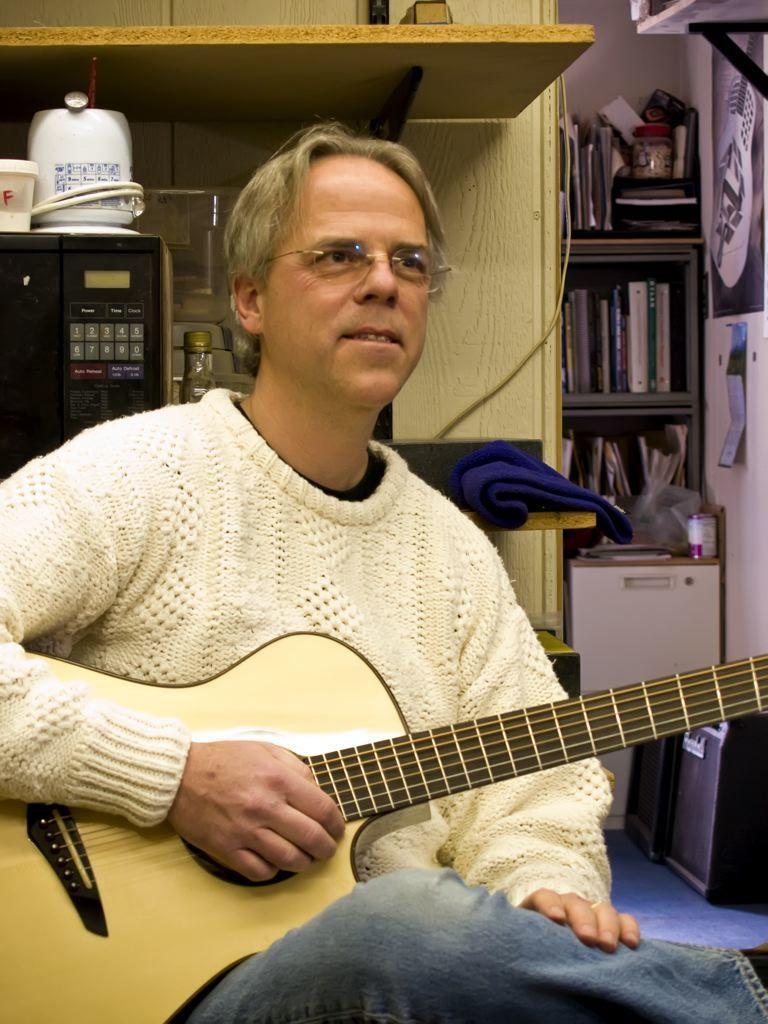In one or two sentences, can you explain what this image depicts? Here we see a man in white sweater is holding guitar in his hands. He is even wearing spectacles. Behind him, we see coffee machine and next to that, we see a cupboard and a rack in which books are placed. This photo is clicked inside the room. 